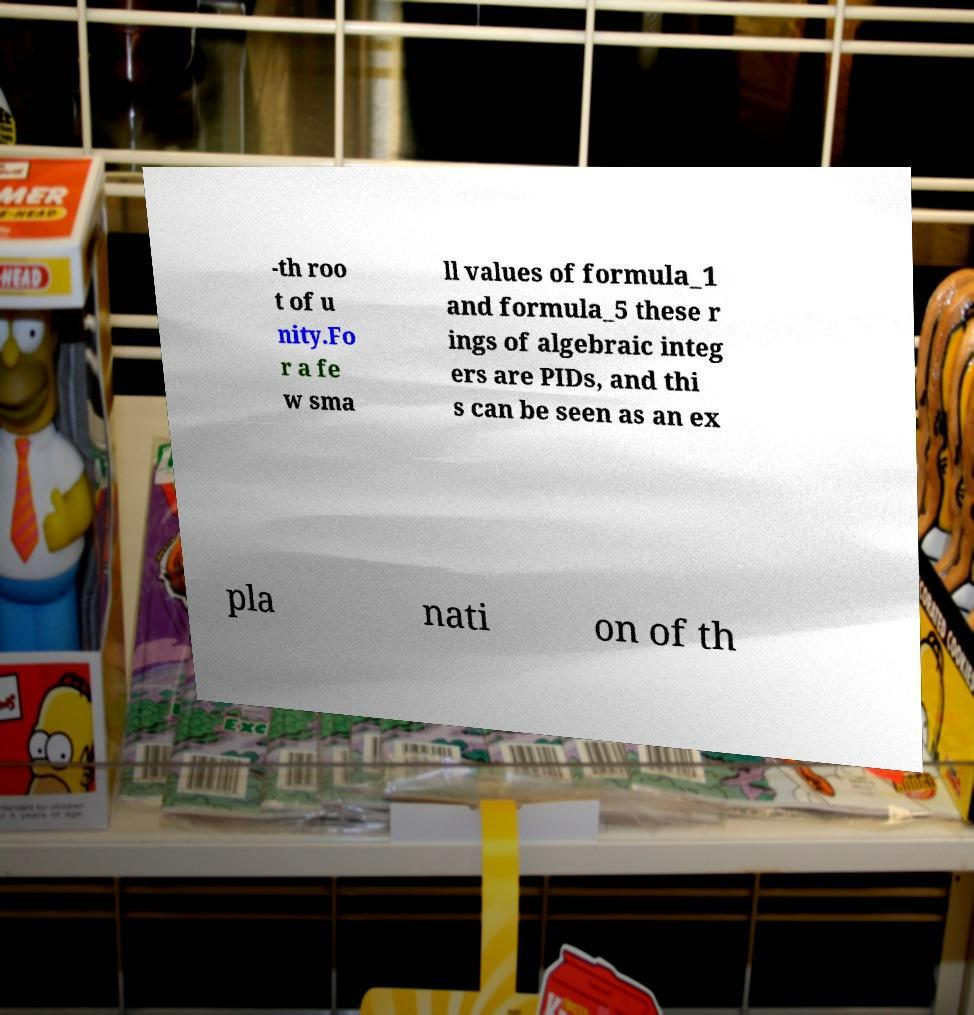Please read and relay the text visible in this image. What does it say? -th roo t of u nity.Fo r a fe w sma ll values of formula_1 and formula_5 these r ings of algebraic integ ers are PIDs, and thi s can be seen as an ex pla nati on of th 